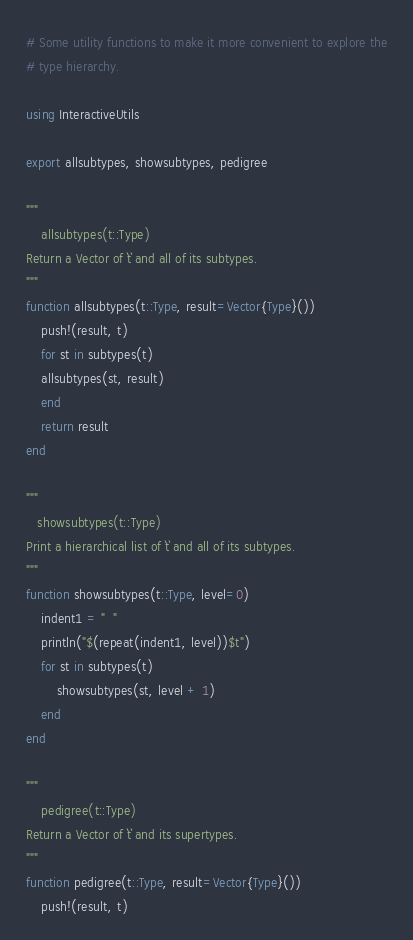Convert code to text. <code><loc_0><loc_0><loc_500><loc_500><_Julia_># Some utility functions to make it more convenient to explore the
# type hierarchy.

using InteractiveUtils

export allsubtypes, showsubtypes, pedigree

"""
    allsubtypes(t::Type)
Return a Vector of `t` and all of its subtypes.
"""
function allsubtypes(t::Type, result=Vector{Type}())
    push!(result, t)
    for st in subtypes(t)
	allsubtypes(st, result)
    end
    return result
end

"""
   showsubtypes(t::Type)
Print a hierarchical list of `t` and all of its subtypes. 
"""
function showsubtypes(t::Type, level=0)
    indent1 = "  "
    println("$(repeat(indent1, level))$t")
    for st in subtypes(t)
        showsubtypes(st, level + 1)
    end
end

"""
    pedigree(t::Type)
Return a Vector of `t` and its supertypes.
"""
function pedigree(t::Type, result=Vector{Type}())
    push!(result, t)</code> 